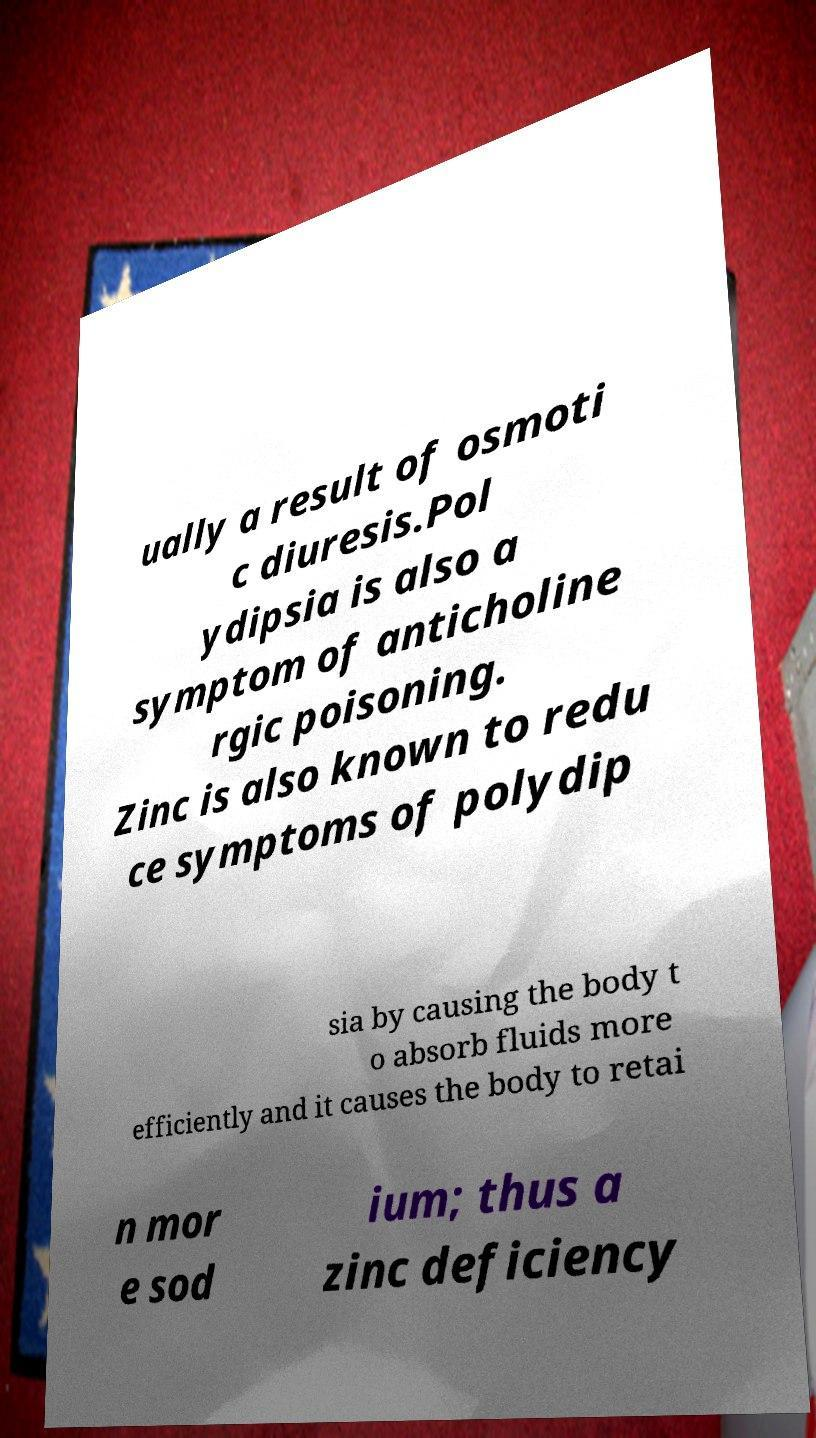Could you extract and type out the text from this image? ually a result of osmoti c diuresis.Pol ydipsia is also a symptom of anticholine rgic poisoning. Zinc is also known to redu ce symptoms of polydip sia by causing the body t o absorb fluids more efficiently and it causes the body to retai n mor e sod ium; thus a zinc deficiency 